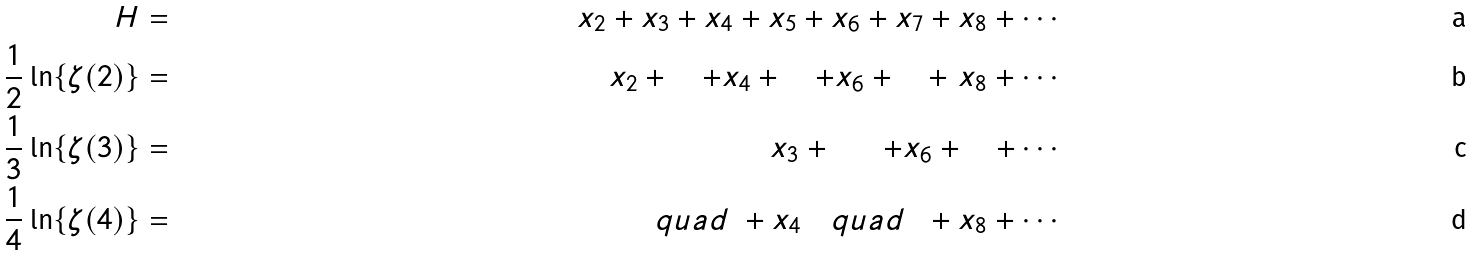Convert formula to latex. <formula><loc_0><loc_0><loc_500><loc_500>H & = & x _ { 2 } + x _ { 3 } + x _ { 4 } + x _ { 5 } + x _ { 6 } + x _ { 7 } + x _ { 8 } + \cdots \\ \frac { 1 } { 2 } \ln \{ \zeta ( 2 ) \} & = & x _ { 2 } + \quad + x _ { 4 } + \quad + x _ { 6 } + \quad + \ x _ { 8 } + \cdots \\ \frac { 1 } { 3 } \ln \{ \zeta ( 3 ) \} & = & \ \quad \ \ x _ { 3 } + \quad \ \ + x _ { 6 } + \quad + \cdots \\ \frac { 1 } { 4 } \ln \{ \zeta ( 4 ) \} & = & \quad \ \ \ q u a d \ + x _ { 4 } \ \ \ q u a d \ \ + x _ { 8 } + \cdots</formula> 